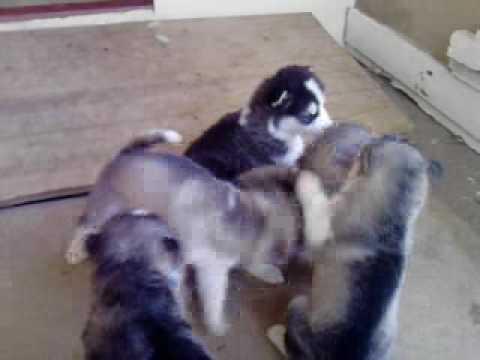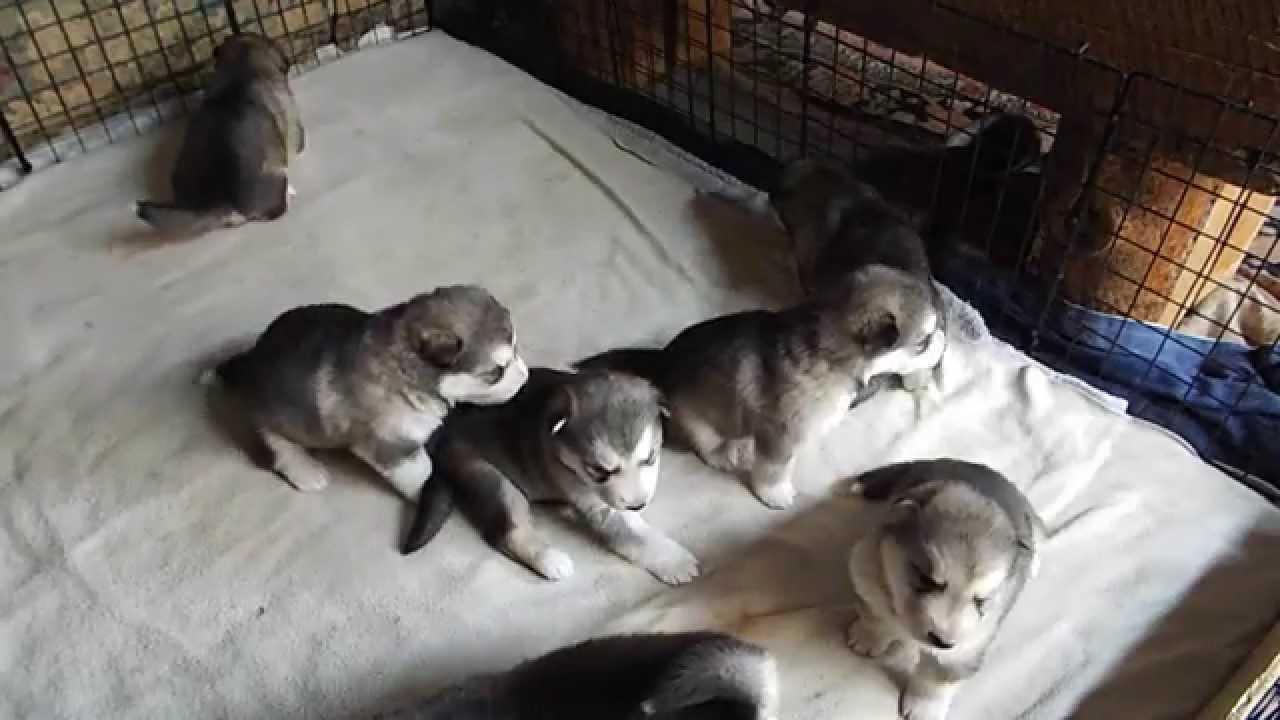The first image is the image on the left, the second image is the image on the right. Given the left and right images, does the statement "There are at most 2 puppies in at least one of the images." hold true? Answer yes or no. No. 